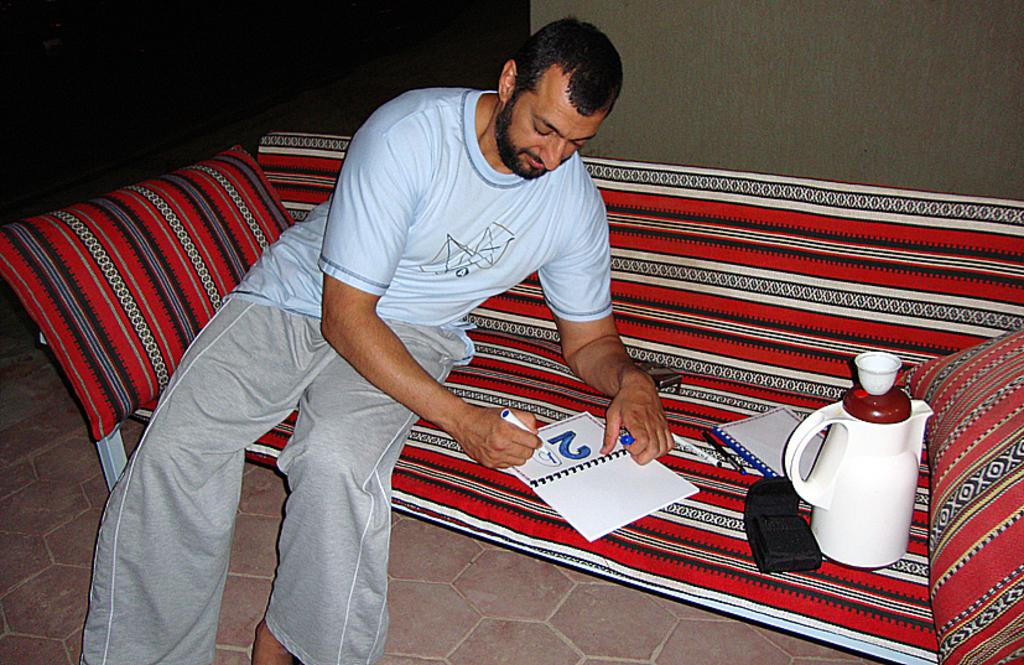Provide a one-sentence caption for the provided image. a man is coloring in the numbers 29 in a book. 